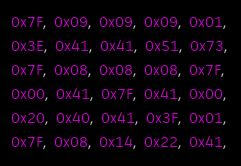<code> <loc_0><loc_0><loc_500><loc_500><_C_>0x7F, 0x09, 0x09, 0x09, 0x01,
0x3E, 0x41, 0x41, 0x51, 0x73,
0x7F, 0x08, 0x08, 0x08, 0x7F,
0x00, 0x41, 0x7F, 0x41, 0x00,
0x20, 0x40, 0x41, 0x3F, 0x01,
0x7F, 0x08, 0x14, 0x22, 0x41,</code> 